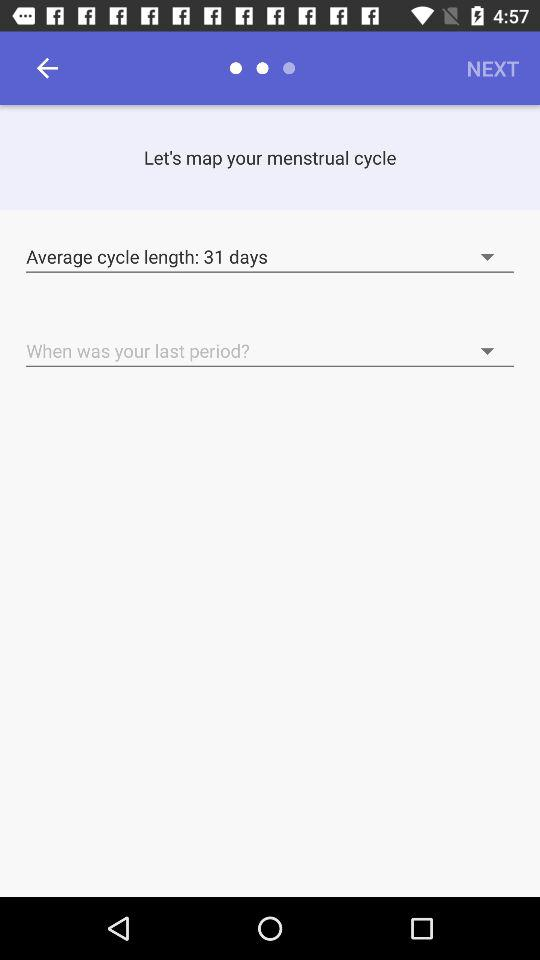How many days is the average cycle length? The average cycle length is 31 days. 